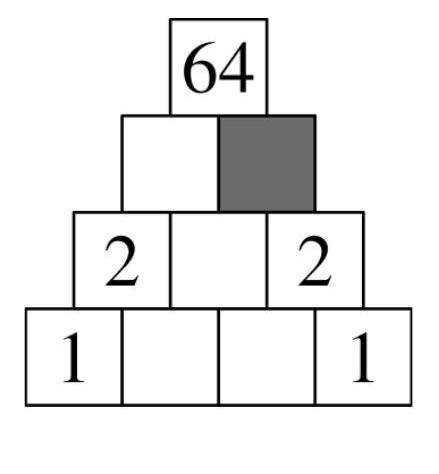Can you explain how the multiplication pyramid works using the numbers on the bottom row? Certainly! In a multiplication pyramid, each number on an upper level is the product of the two numbers directly beneath it. For the bottom row in this image, which has the numbers 1, 1, 2, and 2, multiplying 1 and 1 gives us 1 for the cell directly above them; similarly, multiplying 2 and 2 on the right end gives 4 for the cell above those two numbers. How do we get the number 64 at the top of the pyramid? To reach the number 64 at the top, start by multiplying the results you obtained in the second row: 1 (from 1x1) and 4 (from 2x2). The multiplication of 1 and 4 gives 4 in the middle of the second row. Similarly, the numbers 4 and 2 on the second row, when multiplied (4x2), result in 8 in the third row. The top of the pyramid, 64, is achieved by multiplying this 8 by the middle number of the second row, which is 8 as well. Thus, 8 times 8 gives us 64. 